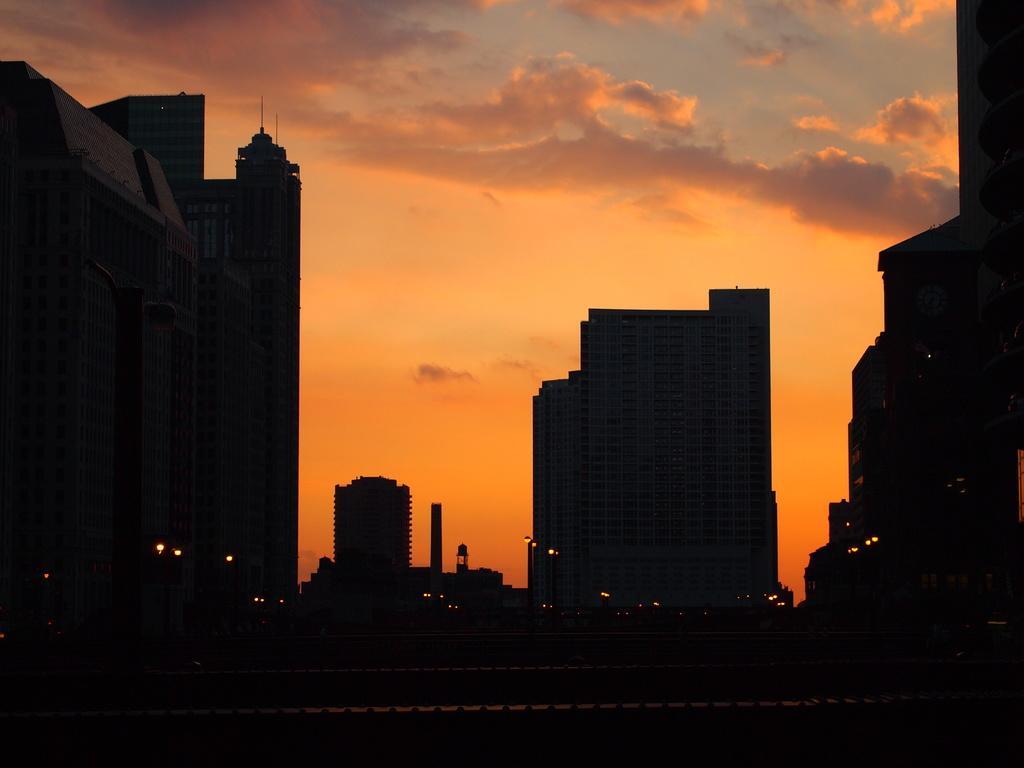In one or two sentences, can you explain what this image depicts? In this picture we can see road, buildings and lights. In the background of the image we can see the sky with clouds. 